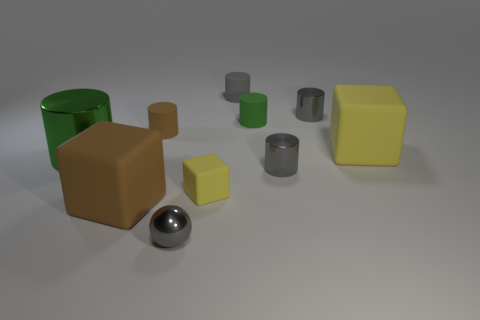Do the small gray matte object and the tiny matte object that is to the left of the gray shiny sphere have the same shape?
Your answer should be very brief. Yes. What size is the green rubber cylinder?
Your response must be concise. Small. Are there fewer matte cubes that are left of the gray matte cylinder than rubber balls?
Keep it short and to the point. No. How many other green cylinders are the same size as the green shiny cylinder?
Your response must be concise. 0. What is the shape of the large thing that is the same color as the small matte block?
Your answer should be compact. Cube. There is a metal cylinder to the left of the gray matte cylinder; is it the same color as the matte cylinder to the right of the gray matte object?
Keep it short and to the point. Yes. There is a brown cylinder; how many cylinders are right of it?
Your response must be concise. 4. What is the size of the other cube that is the same color as the small rubber cube?
Keep it short and to the point. Large. Are there any large brown metallic things that have the same shape as the small brown rubber thing?
Provide a short and direct response. No. There is a block that is the same size as the gray rubber cylinder; what color is it?
Make the answer very short. Yellow. 